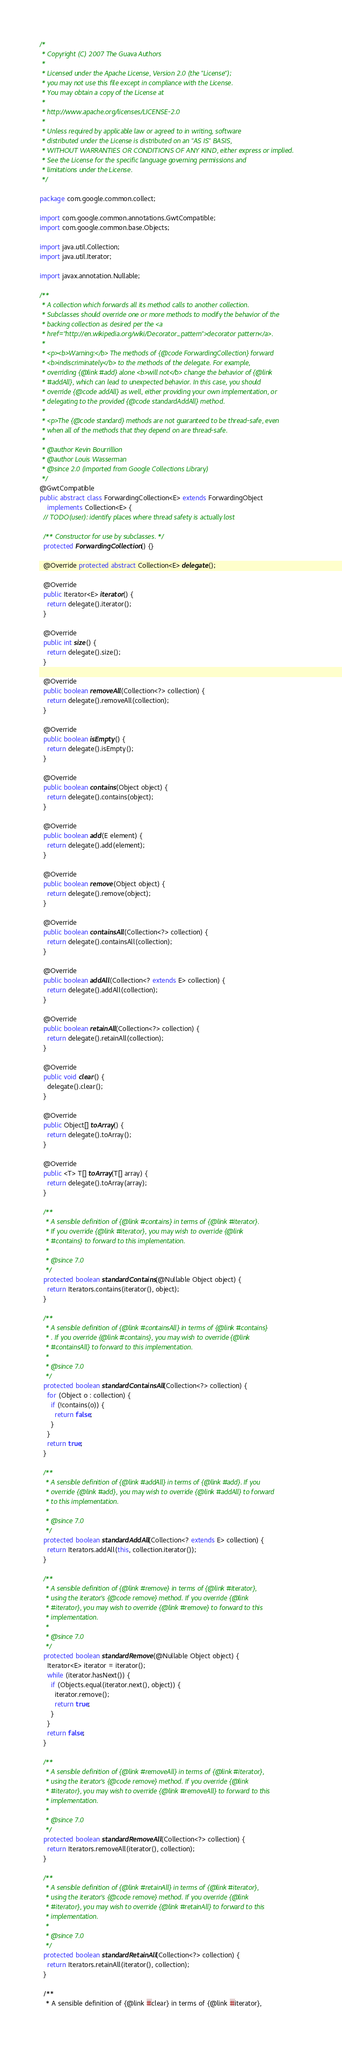Convert code to text. <code><loc_0><loc_0><loc_500><loc_500><_Java_>/*
 * Copyright (C) 2007 The Guava Authors
 *
 * Licensed under the Apache License, Version 2.0 (the "License");
 * you may not use this file except in compliance with the License.
 * You may obtain a copy of the License at
 *
 * http://www.apache.org/licenses/LICENSE-2.0
 *
 * Unless required by applicable law or agreed to in writing, software
 * distributed under the License is distributed on an "AS IS" BASIS,
 * WITHOUT WARRANTIES OR CONDITIONS OF ANY KIND, either express or implied.
 * See the License for the specific language governing permissions and
 * limitations under the License.
 */

package com.google.common.collect;

import com.google.common.annotations.GwtCompatible;
import com.google.common.base.Objects;

import java.util.Collection;
import java.util.Iterator;

import javax.annotation.Nullable;

/**
 * A collection which forwards all its method calls to another collection.
 * Subclasses should override one or more methods to modify the behavior of the
 * backing collection as desired per the <a
 * href="http://en.wikipedia.org/wiki/Decorator_pattern">decorator pattern</a>.
 *
 * <p><b>Warning:</b> The methods of {@code ForwardingCollection} forward
 * <b>indiscriminately</b> to the methods of the delegate. For example,
 * overriding {@link #add} alone <b>will not</b> change the behavior of {@link
 * #addAll}, which can lead to unexpected behavior. In this case, you should
 * override {@code addAll} as well, either providing your own implementation, or
 * delegating to the provided {@code standardAddAll} method.
 *
 * <p>The {@code standard} methods are not guaranteed to be thread-safe, even
 * when all of the methods that they depend on are thread-safe.
 *
 * @author Kevin Bourrillion
 * @author Louis Wasserman
 * @since 2.0 (imported from Google Collections Library)
 */
@GwtCompatible
public abstract class ForwardingCollection<E> extends ForwardingObject
    implements Collection<E> {
  // TODO(user): identify places where thread safety is actually lost

  /** Constructor for use by subclasses. */
  protected ForwardingCollection() {}

  @Override protected abstract Collection<E> delegate();

  @Override
  public Iterator<E> iterator() {
    return delegate().iterator();
  }

  @Override
  public int size() {
    return delegate().size();
  }

  @Override
  public boolean removeAll(Collection<?> collection) {
    return delegate().removeAll(collection);
  }

  @Override
  public boolean isEmpty() {
    return delegate().isEmpty();
  }

  @Override
  public boolean contains(Object object) {
    return delegate().contains(object);
  }

  @Override
  public boolean add(E element) {
    return delegate().add(element);
  }

  @Override
  public boolean remove(Object object) {
    return delegate().remove(object);
  }

  @Override
  public boolean containsAll(Collection<?> collection) {
    return delegate().containsAll(collection);
  }

  @Override
  public boolean addAll(Collection<? extends E> collection) {
    return delegate().addAll(collection);
  }

  @Override
  public boolean retainAll(Collection<?> collection) {
    return delegate().retainAll(collection);
  }

  @Override
  public void clear() {
    delegate().clear();
  }

  @Override
  public Object[] toArray() {
    return delegate().toArray();
  }

  @Override
  public <T> T[] toArray(T[] array) {
    return delegate().toArray(array);
  }

  /**
   * A sensible definition of {@link #contains} in terms of {@link #iterator}.
   * If you override {@link #iterator}, you may wish to override {@link
   * #contains} to forward to this implementation.
   *
   * @since 7.0
   */
  protected boolean standardContains(@Nullable Object object) {
    return Iterators.contains(iterator(), object);
  }

  /**
   * A sensible definition of {@link #containsAll} in terms of {@link #contains}
   * . If you override {@link #contains}, you may wish to override {@link
   * #containsAll} to forward to this implementation.
   *
   * @since 7.0
   */
  protected boolean standardContainsAll(Collection<?> collection) {
    for (Object o : collection) {
      if (!contains(o)) {
        return false;
      }
    }
    return true;
  }

  /**
   * A sensible definition of {@link #addAll} in terms of {@link #add}. If you
   * override {@link #add}, you may wish to override {@link #addAll} to forward
   * to this implementation.
   *
   * @since 7.0
   */
  protected boolean standardAddAll(Collection<? extends E> collection) {
    return Iterators.addAll(this, collection.iterator());
  }

  /**
   * A sensible definition of {@link #remove} in terms of {@link #iterator},
   * using the iterator's {@code remove} method. If you override {@link
   * #iterator}, you may wish to override {@link #remove} to forward to this
   * implementation.
   *
   * @since 7.0
   */
  protected boolean standardRemove(@Nullable Object object) {
    Iterator<E> iterator = iterator();
    while (iterator.hasNext()) {
      if (Objects.equal(iterator.next(), object)) {
        iterator.remove();
        return true;
      }
    }
    return false;
  }

  /**
   * A sensible definition of {@link #removeAll} in terms of {@link #iterator},
   * using the iterator's {@code remove} method. If you override {@link
   * #iterator}, you may wish to override {@link #removeAll} to forward to this
   * implementation.
   *
   * @since 7.0
   */
  protected boolean standardRemoveAll(Collection<?> collection) {
    return Iterators.removeAll(iterator(), collection);
  }

  /**
   * A sensible definition of {@link #retainAll} in terms of {@link #iterator},
   * using the iterator's {@code remove} method. If you override {@link
   * #iterator}, you may wish to override {@link #retainAll} to forward to this
   * implementation.
   *
   * @since 7.0
   */
  protected boolean standardRetainAll(Collection<?> collection) {
    return Iterators.retainAll(iterator(), collection);
  }

  /**
   * A sensible definition of {@link #clear} in terms of {@link #iterator},</code> 